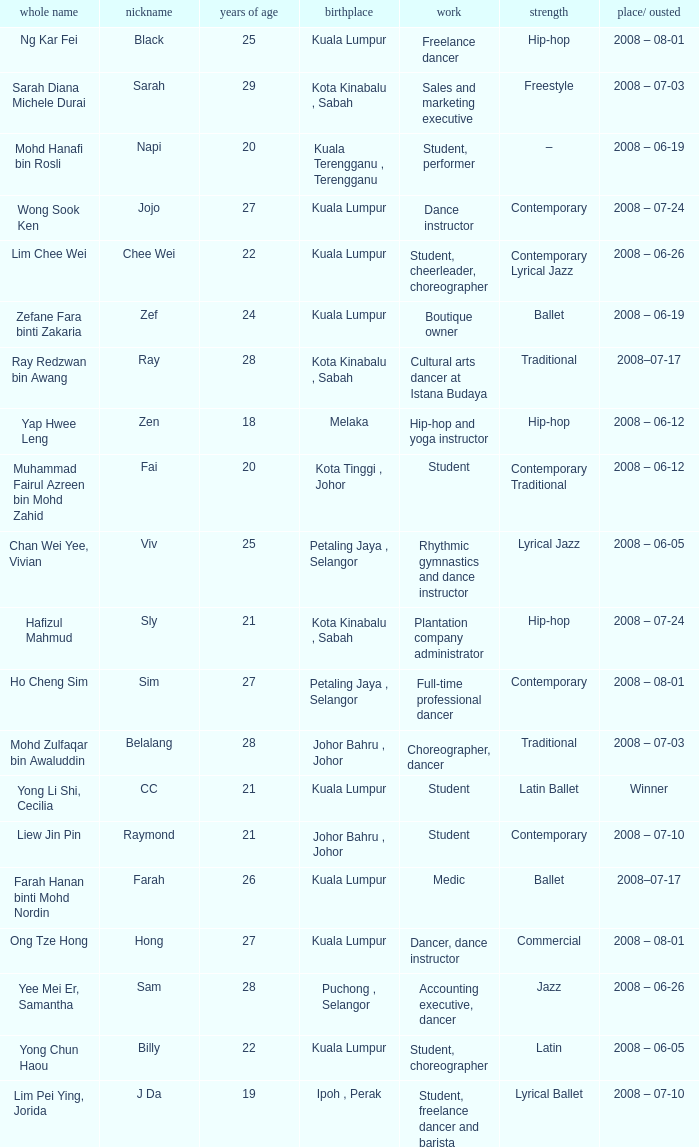What is Full Name, when Age¹ is "20", and when Occupation² is "Student"? Muhammad Fairul Azreen bin Mohd Zahid. 